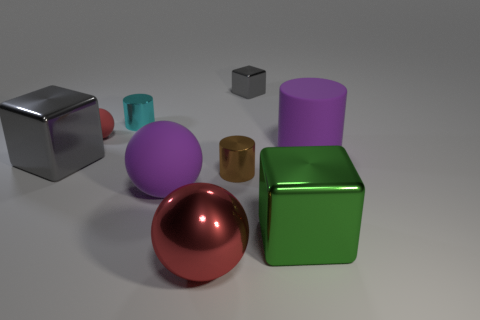Is the material of the cylinder right of the tiny gray cube the same as the small thing that is in front of the tiny red rubber object?
Give a very brief answer. No. What shape is the purple object that is behind the gray thing that is in front of the purple cylinder?
Your answer should be very brief. Cylinder. What color is the sphere that is made of the same material as the small gray object?
Offer a terse response. Red. Is the large cylinder the same color as the tiny cube?
Give a very brief answer. No. What is the shape of the brown thing that is the same size as the cyan metallic cylinder?
Offer a very short reply. Cylinder. What size is the brown cylinder?
Keep it short and to the point. Small. There is a cylinder that is right of the green object; is it the same size as the matte object that is left of the cyan metal cylinder?
Your response must be concise. No. What is the color of the big metallic block behind the small brown metallic cylinder behind the big red metal sphere?
Give a very brief answer. Gray. There is a block that is the same size as the cyan object; what is its material?
Make the answer very short. Metal. What number of metal things are either small cubes or balls?
Make the answer very short. 2. 